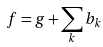<formula> <loc_0><loc_0><loc_500><loc_500>f = g + \sum _ { k } b _ { k }</formula> 